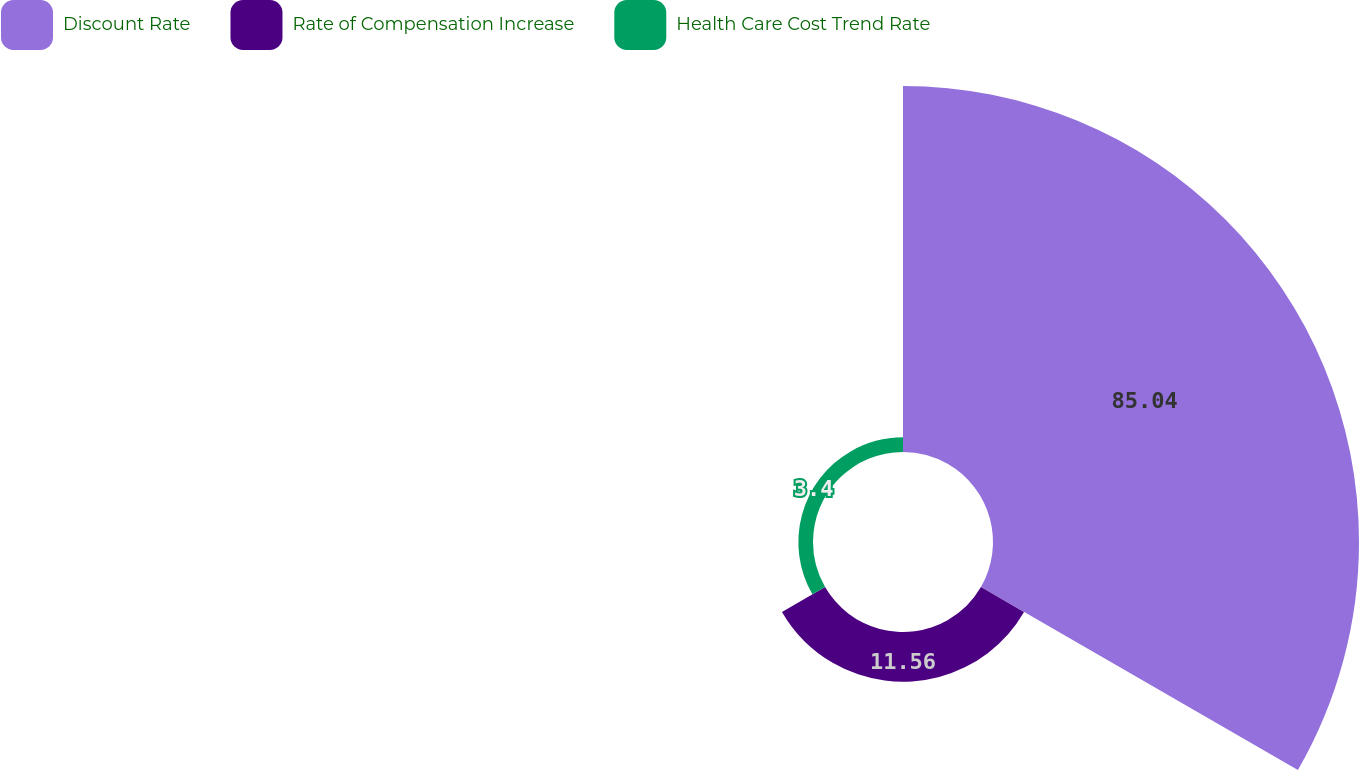<chart> <loc_0><loc_0><loc_500><loc_500><pie_chart><fcel>Discount Rate<fcel>Rate of Compensation Increase<fcel>Health Care Cost Trend Rate<nl><fcel>85.03%<fcel>11.56%<fcel>3.4%<nl></chart> 